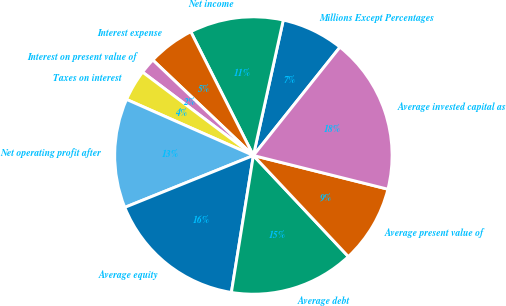<chart> <loc_0><loc_0><loc_500><loc_500><pie_chart><fcel>Millions Except Percentages<fcel>Net income<fcel>Interest expense<fcel>Interest on present value of<fcel>Taxes on interest<fcel>Net operating profit after<fcel>Average equity<fcel>Average debt<fcel>Average present value of<fcel>Average invested capital as<nl><fcel>7.27%<fcel>10.91%<fcel>5.46%<fcel>1.82%<fcel>3.64%<fcel>12.73%<fcel>16.36%<fcel>14.54%<fcel>9.09%<fcel>18.18%<nl></chart> 